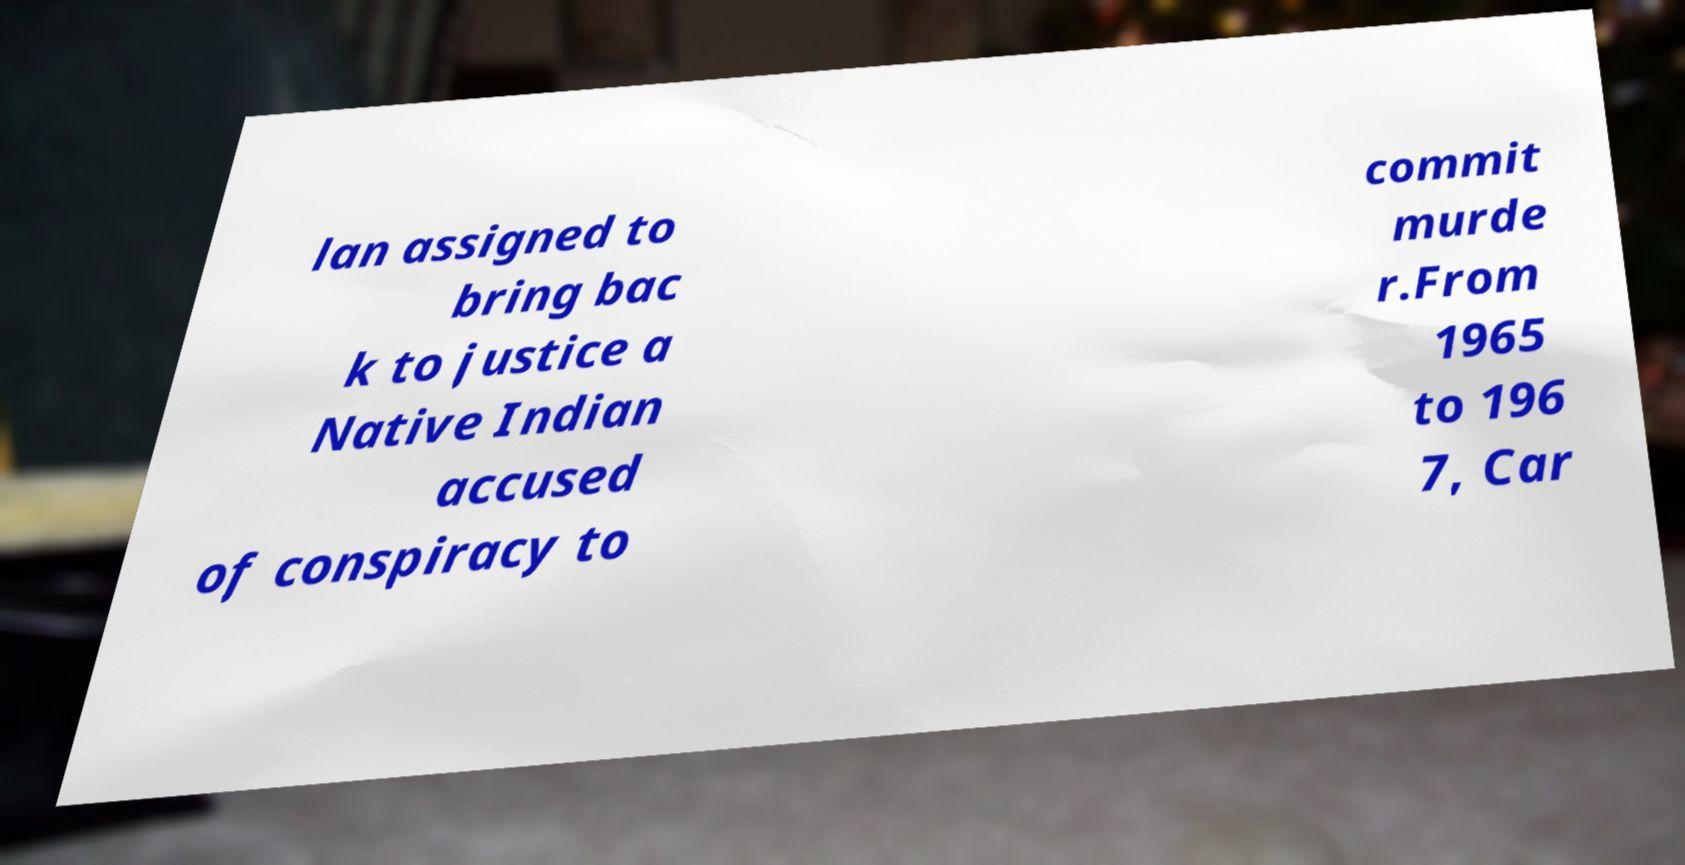Could you extract and type out the text from this image? lan assigned to bring bac k to justice a Native Indian accused of conspiracy to commit murde r.From 1965 to 196 7, Car 